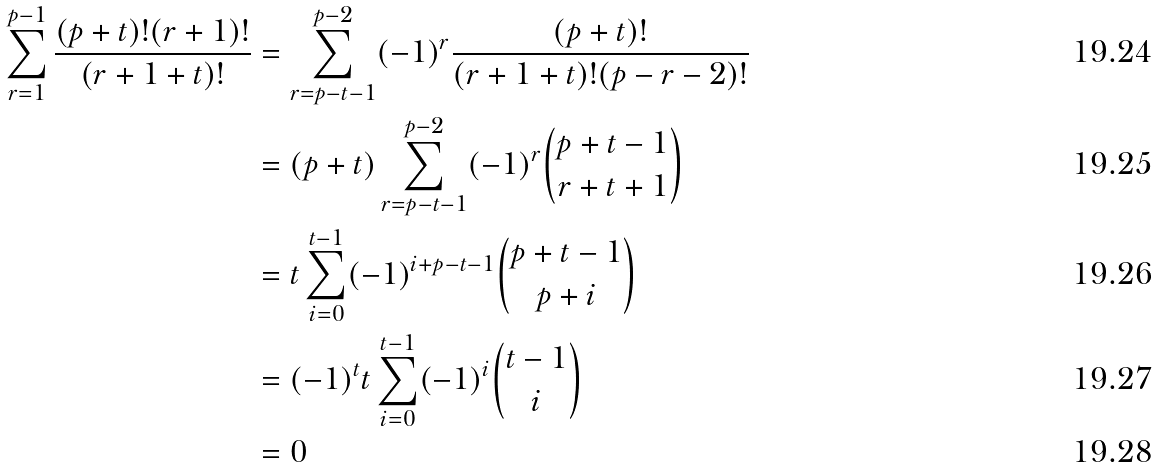<formula> <loc_0><loc_0><loc_500><loc_500>\sum _ { r = 1 } ^ { p - 1 } \frac { ( p + t ) ! ( r + 1 ) ! } { ( r + 1 + t ) ! } & = \sum _ { r = p - t - 1 } ^ { p - 2 } ( - 1 ) ^ { r } \frac { ( p + t ) ! } { ( r + 1 + t ) ! ( p - r - 2 ) ! } \\ & = ( p + t ) \sum _ { r = p - t - 1 } ^ { p - 2 } ( - 1 ) ^ { r } \binom { p + t - 1 } { r + t + 1 } \\ & = t \sum _ { i = 0 } ^ { t - 1 } ( - 1 ) ^ { i + p - t - 1 } \binom { p + t - 1 } { p + i } \\ & = ( - 1 ) ^ { t } t \sum _ { i = 0 } ^ { t - 1 } ( - 1 ) ^ { i } \binom { t - 1 } { i } \\ & = 0</formula> 